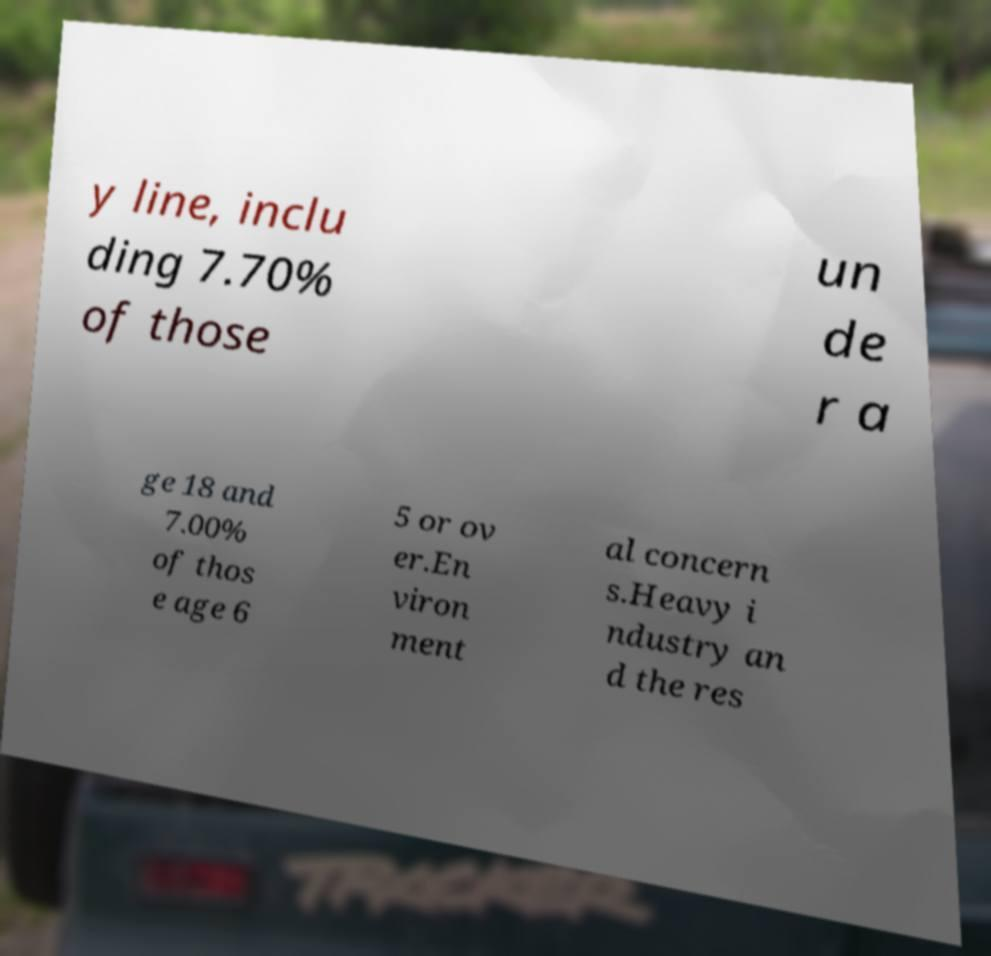Could you assist in decoding the text presented in this image and type it out clearly? y line, inclu ding 7.70% of those un de r a ge 18 and 7.00% of thos e age 6 5 or ov er.En viron ment al concern s.Heavy i ndustry an d the res 